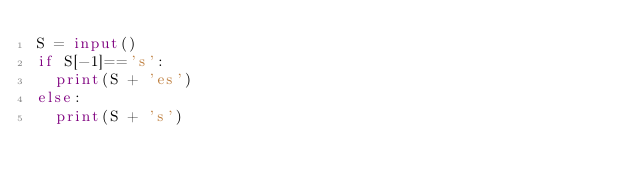Convert code to text. <code><loc_0><loc_0><loc_500><loc_500><_Python_>S = input()
if S[-1]=='s':
  print(S + 'es')
else:
  print(S + 's')</code> 